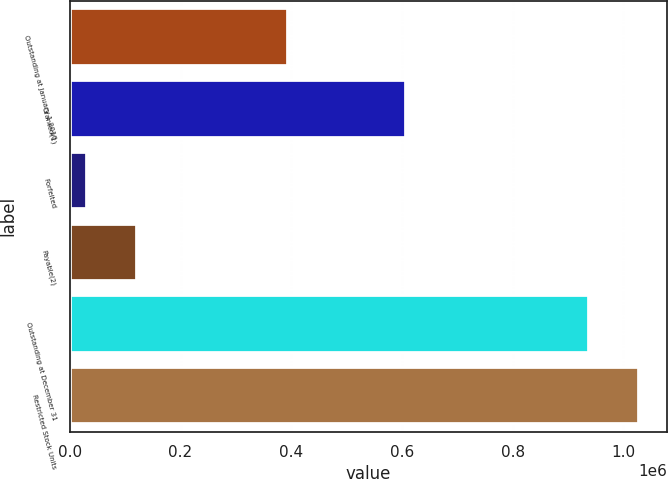Convert chart. <chart><loc_0><loc_0><loc_500><loc_500><bar_chart><fcel>Outstanding at January 1 2010<fcel>Granted(1)<fcel>Forfeited<fcel>Payable(2)<fcel>Outstanding at December 31<fcel>Restricted Stock Units<nl><fcel>393362<fcel>607200<fcel>31275<fcel>121865<fcel>937172<fcel>1.02776e+06<nl></chart> 